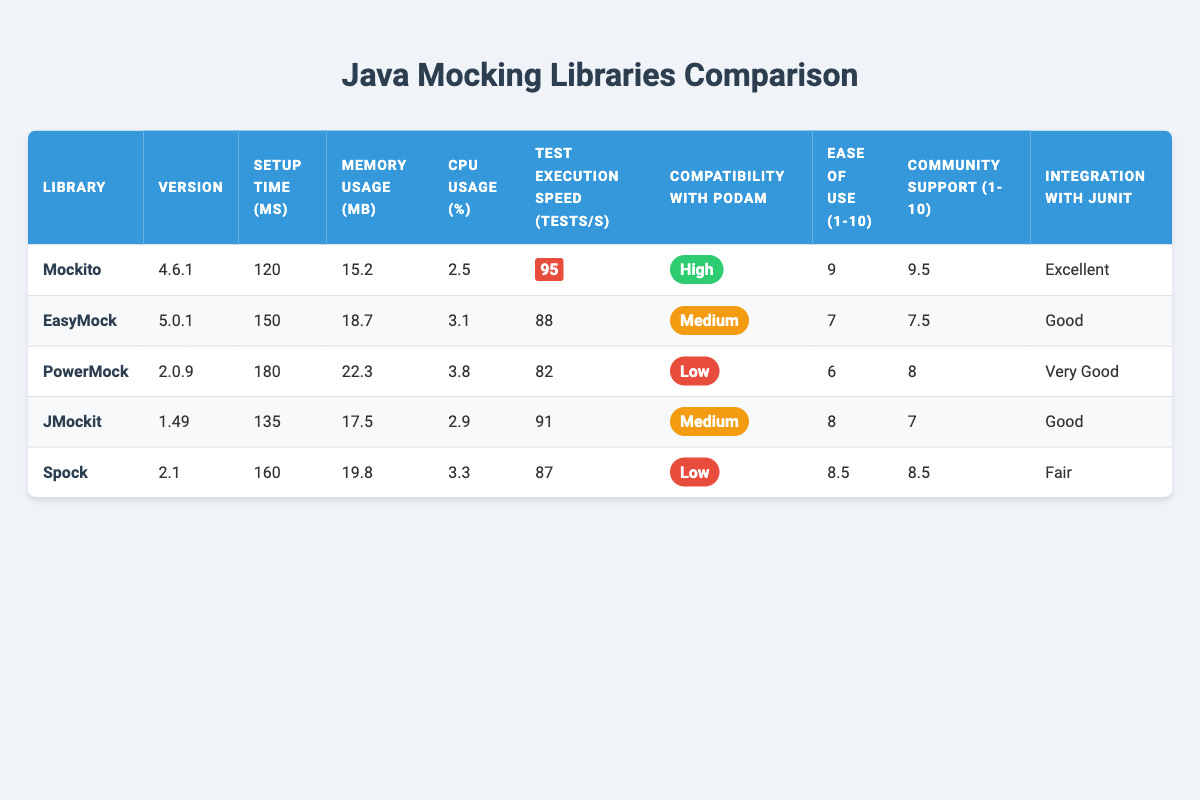What is the setup time for Mockito? The setup time for Mockito is directly listed in the table under the "Setup Time (ms)" column, which shows 120 milliseconds.
Answer: 120 milliseconds Which library has the highest community support rating? By examining the "Community Support (1-10)" column, Mockito has the highest rating of 9.5, compared to the others.
Answer: Mockito What is the average test execution speed of EasyMock and PowerMock? The test execution speeds are 88 tests/second for EasyMock and 82 tests/second for PowerMock. The average is (88 + 82) / 2 = 85 tests/second.
Answer: 85 tests/second Which mocking library has the lowest CPU usage? Checking the "CPU Usage (%)" column, Mockito has the lowest CPU usage at 2.5%, compared to the others.
Answer: Mockito Is JMockit more compatible with Podam than PowerMock? According to the "Compatibility with Podam" column, JMockit has a "Medium" rating while PowerMock has a "Low" rating, meaning JMockit is indeed more compatible.
Answer: Yes How much more memory does Spock use compared to Mockito? The memory usage for Spock is 19.8 MB and for Mockito it is 15.2 MB. The difference is 19.8 - 15.2 = 4.6 MB.
Answer: 4.6 MB Which library integrates with JUnit at a level lower than "Very Good"? The integration levels with JUnit are listed in the table; EasyMock and Spock both have "Good" and "Fair," respectively, which are lower than "Very Good."
Answer: EasyMock and Spock What is the sum of the setup times for all libraries? The setup times are 120 ms (Mockito), 150 ms (EasyMock), 180 ms (PowerMock), 135 ms (JMockit), and 160 ms (Spock). Summing these gives 120 + 150 + 180 + 135 + 160 = 745 ms.
Answer: 745 ms Which mocking library has better ease of use, EasyMock or JMockit? The table lists Ease of Use ratings as 7 for EasyMock and 8 for JMockit, indicating that JMockit has better ease of use.
Answer: JMockit 